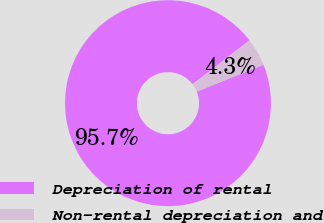<chart> <loc_0><loc_0><loc_500><loc_500><pie_chart><fcel>Depreciation of rental<fcel>Non-rental depreciation and<nl><fcel>95.65%<fcel>4.35%<nl></chart> 